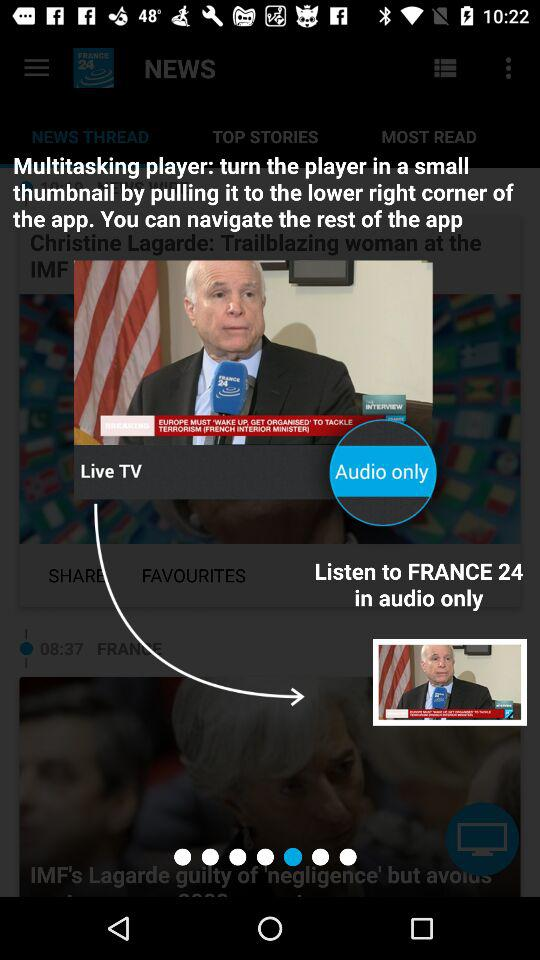How to navigate the app?
When the provided information is insufficient, respond with <no answer>. <no answer> 